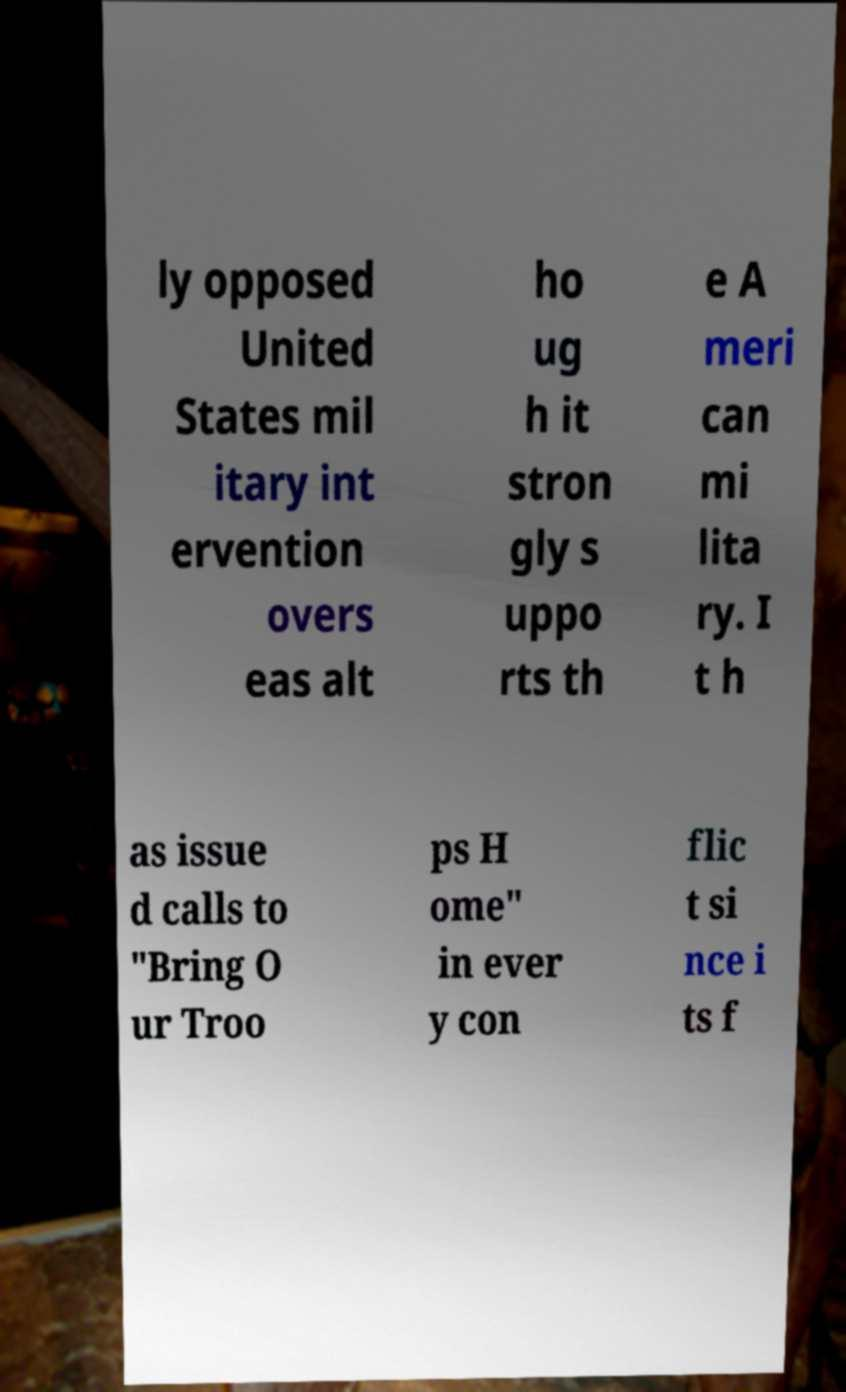There's text embedded in this image that I need extracted. Can you transcribe it verbatim? ly opposed United States mil itary int ervention overs eas alt ho ug h it stron gly s uppo rts th e A meri can mi lita ry. I t h as issue d calls to "Bring O ur Troo ps H ome" in ever y con flic t si nce i ts f 